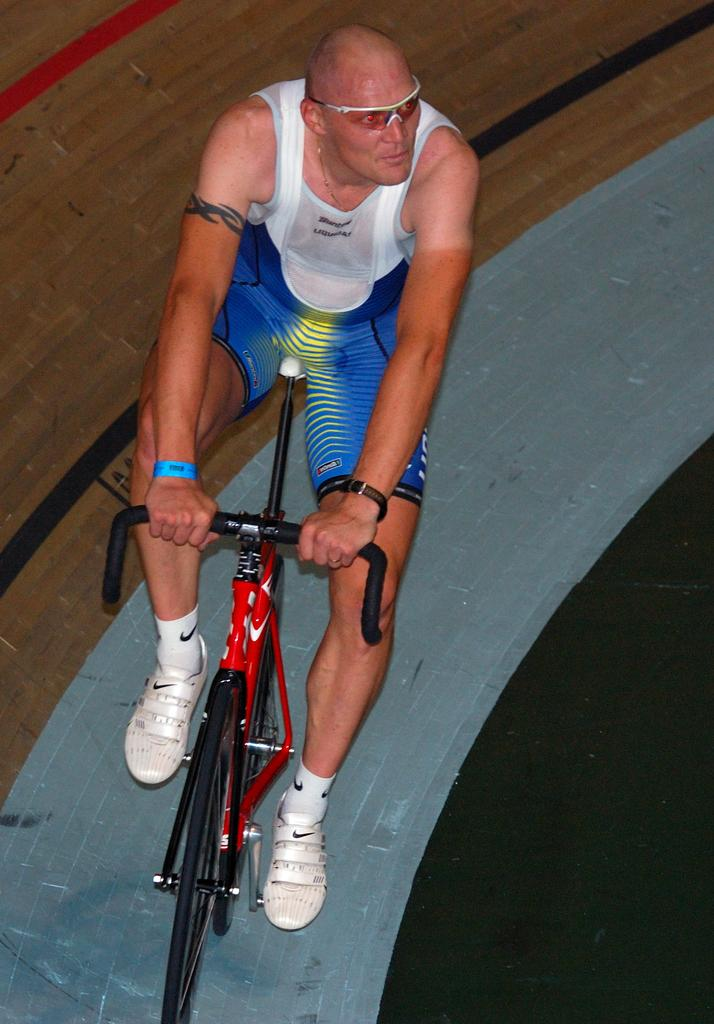Who is the main subject in the image? There is a man in the image. What is the man wearing on his face? The man is wearing goggles. What is the man wearing on his wrist? The man is wearing a wristband. What activity is the man engaged in? The man is riding a bicycle. What type of destruction is the man causing while riding the bicycle in the image? There is no destruction present in the image; the man is simply riding a bicycle. 